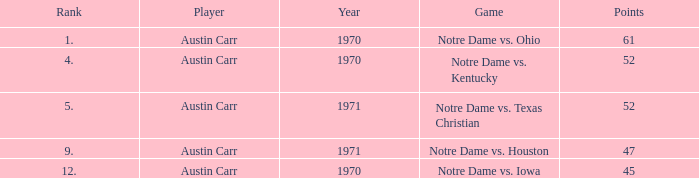Which Rank is the lowest one that has Points larger than 52, and a Year larger than 1970? None. 